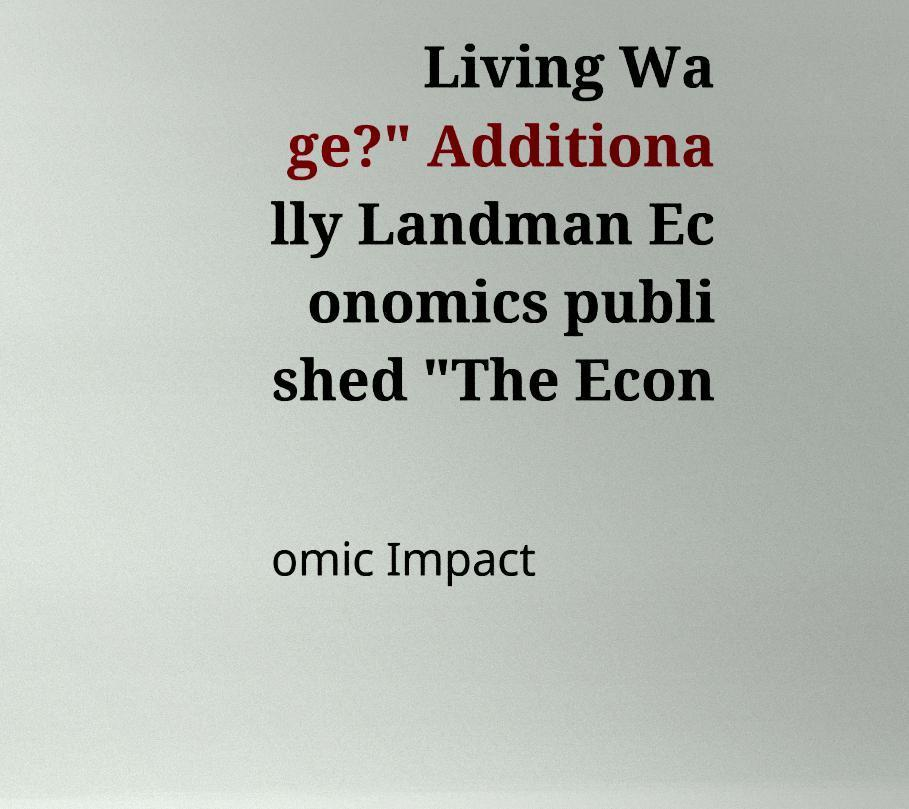Please identify and transcribe the text found in this image. Living Wa ge?" Additiona lly Landman Ec onomics publi shed "The Econ omic Impact 